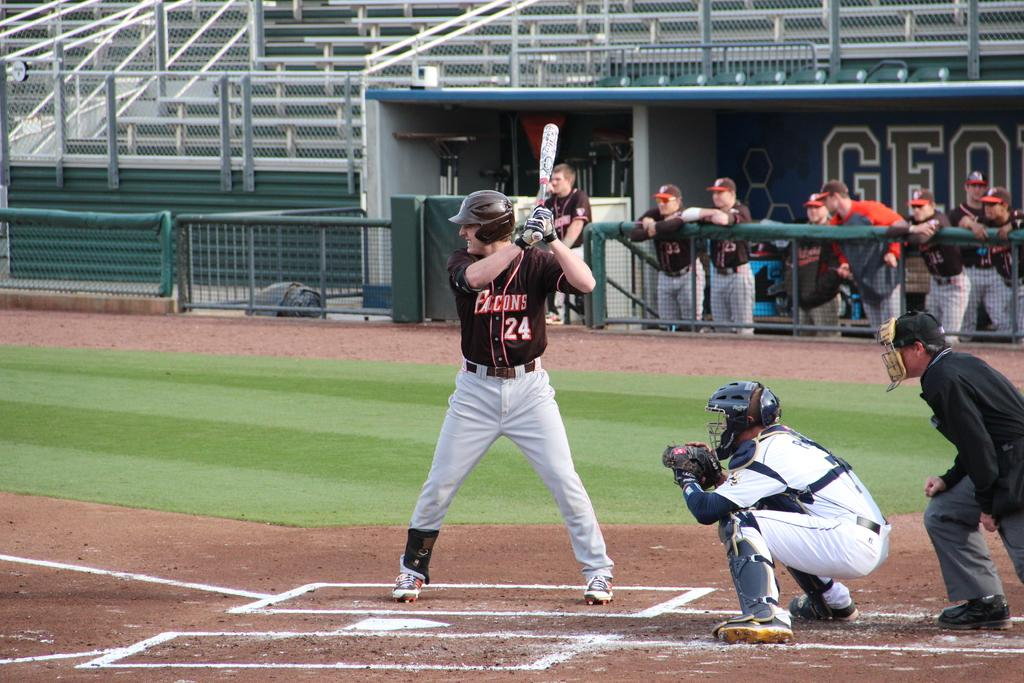<image>
Describe the image concisely. Baseball player for the Falcons batting at the base. 